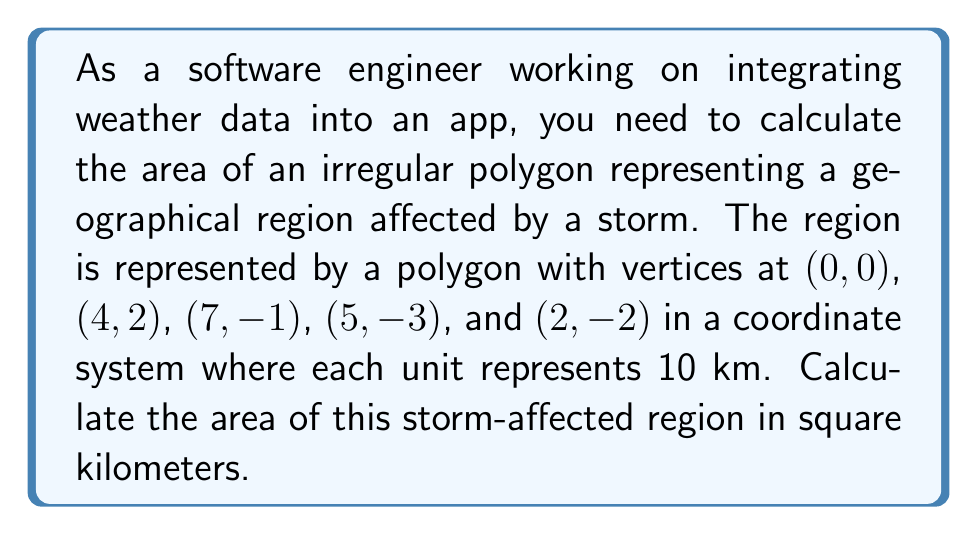Help me with this question. To calculate the area of an irregular polygon, we can use the Shoelace formula (also known as the surveyor's formula). The steps are as follows:

1) First, let's list our vertices in order:
   $(x_1, y_1) = (0, 0)$
   $(x_2, y_2) = (4, 2)$
   $(x_3, y_3) = (7, -1)$
   $(x_4, y_4) = (5, -3)$
   $(x_5, y_5) = (2, -2)$

2) The Shoelace formula for the area is:

   $$A = \frac{1}{2}|\sum_{i=1}^{n-1} (x_i y_{i+1} - x_{i+1} y_i) + (x_n y_1 - x_1 y_n)|$$

3) Let's calculate each term:
   $(0 \cdot 2 - 4 \cdot 0) = 0$
   $(4 \cdot (-1) - 7 \cdot 2) = -18$
   $(7 \cdot (-3) - 5 \cdot (-1)) = -16$
   $(5 \cdot (-2) - 2 \cdot (-3)) = -4$
   $(2 \cdot 0 - 0 \cdot (-2)) = 0$

4) Sum these terms:
   $0 + (-18) + (-16) + (-4) + 0 = -38$

5) Take the absolute value and divide by 2:
   $\frac{1}{2}|-38| = 19$

6) This gives us the area in square units. Since each unit represents 10 km, we need to multiply by $10^2 = 100$ to get square kilometers:
   $19 \cdot 100 = 1900$

Therefore, the area of the storm-affected region is 1900 square kilometers.
Answer: 1900 km² 